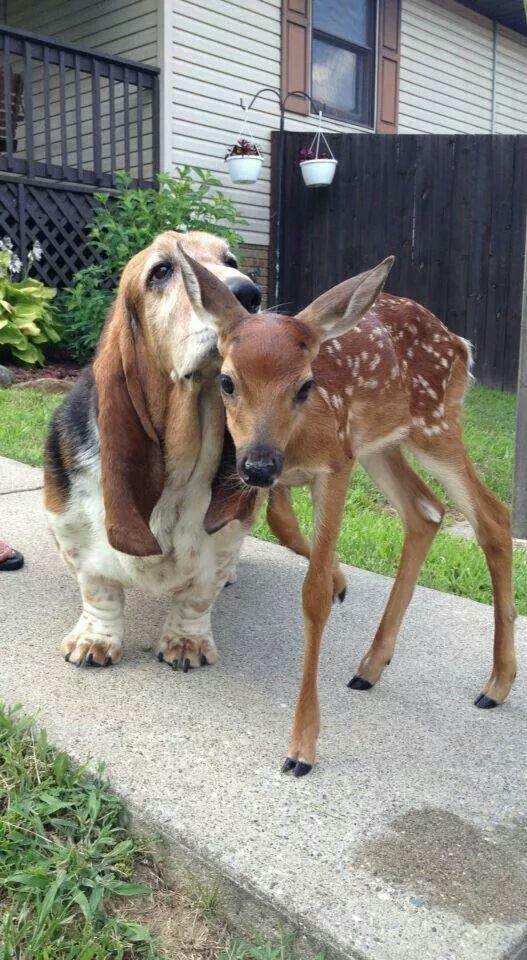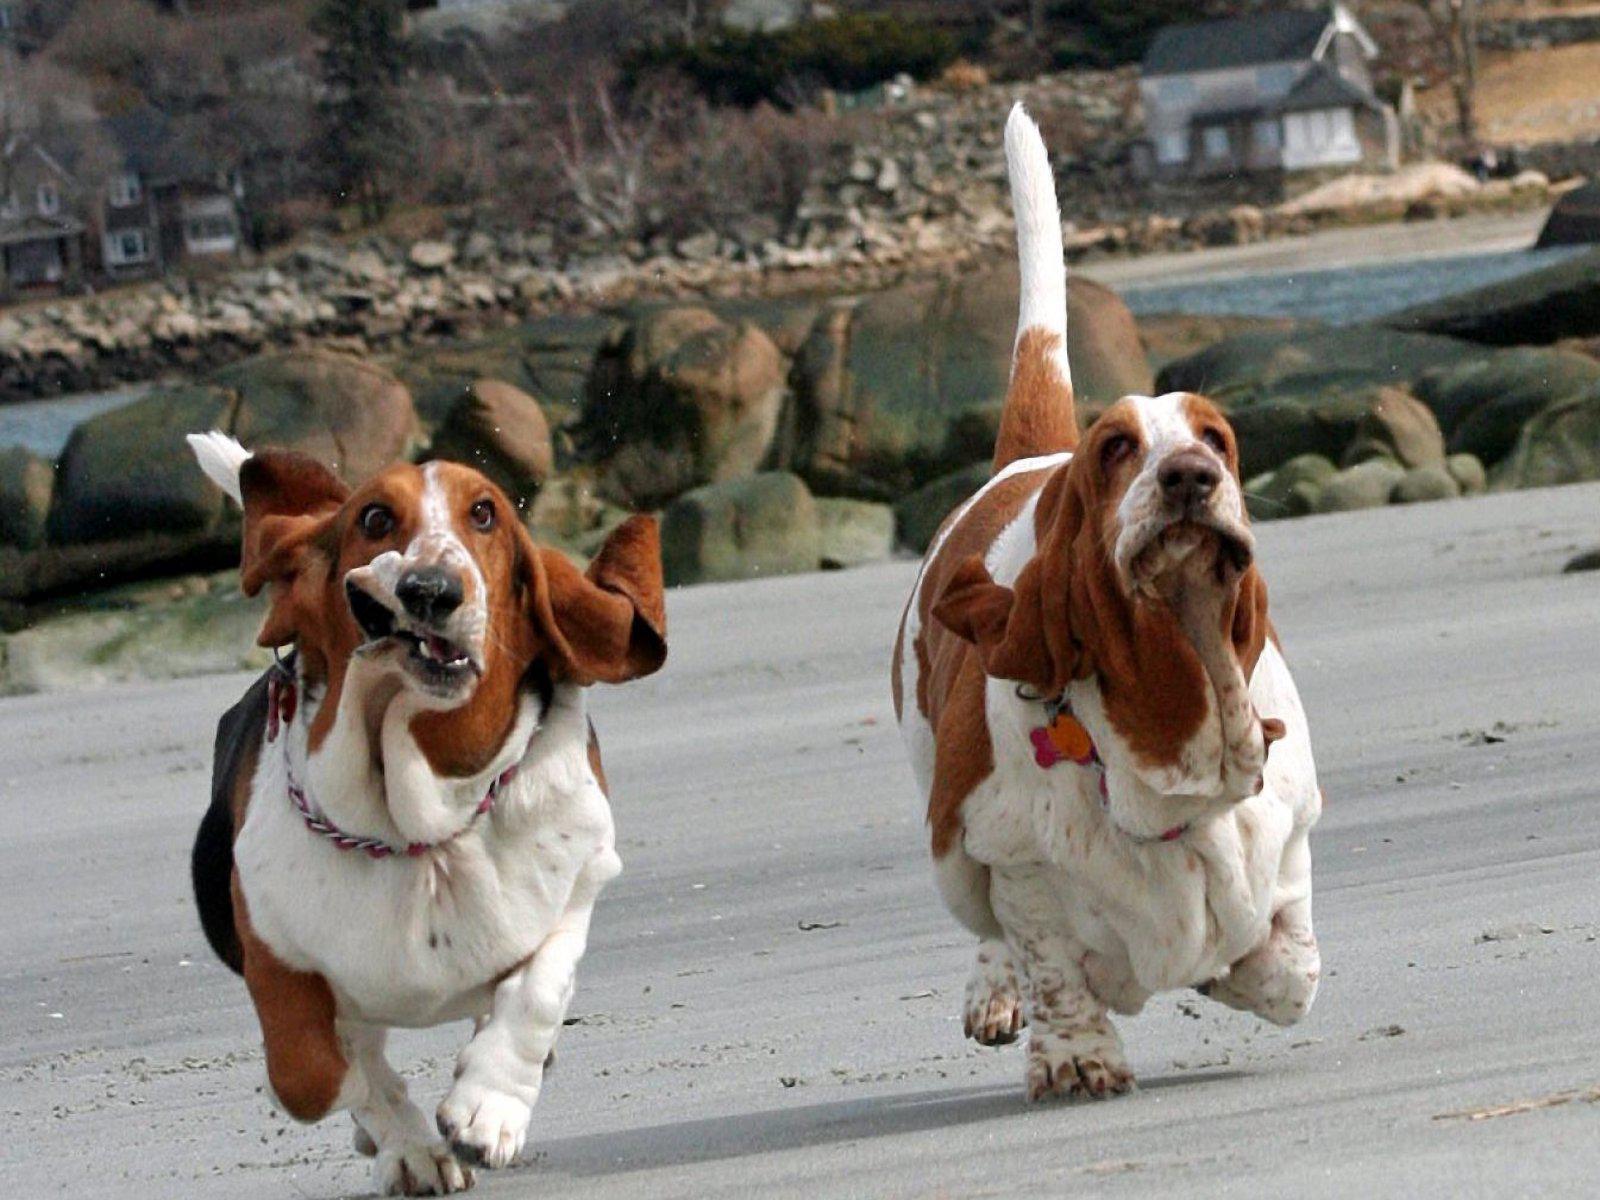The first image is the image on the left, the second image is the image on the right. Analyze the images presented: Is the assertion "An image shows two basset hounds side-by-side outdoors, and at least one has its loose jowls flapping." valid? Answer yes or no. Yes. The first image is the image on the left, the second image is the image on the right. Considering the images on both sides, is "There are three dogs." valid? Answer yes or no. Yes. 